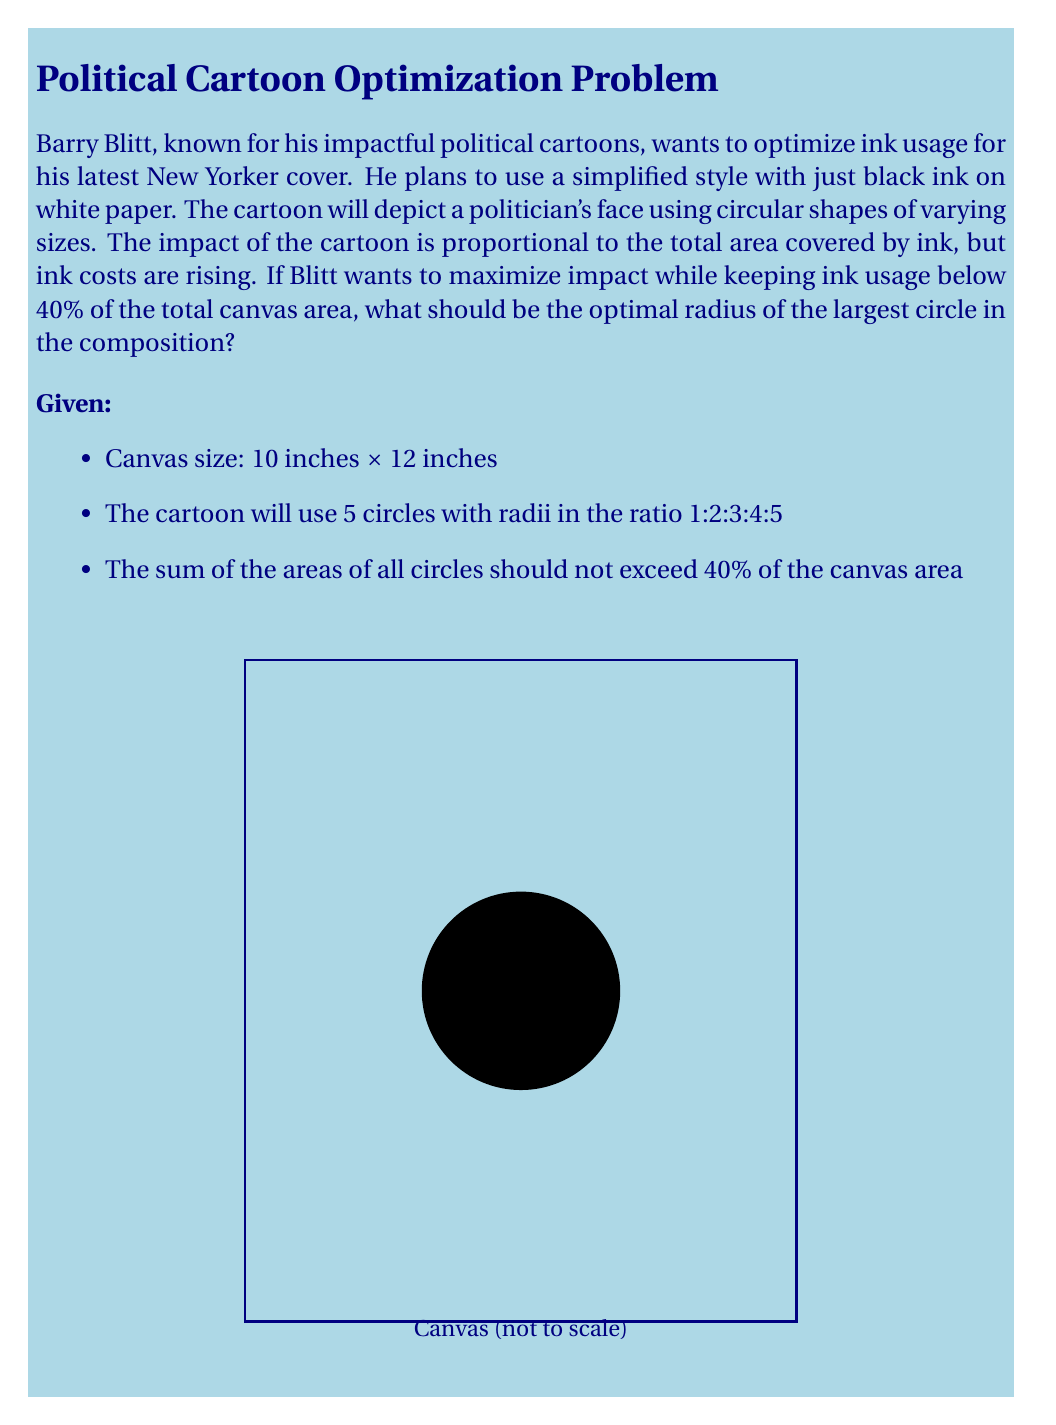Teach me how to tackle this problem. Let's approach this step-by-step:

1) First, calculate the total canvas area:
   $A_{canvas} = 10 \text{ in} \times 12 \text{ in} = 120 \text{ in}^2$

2) The maximum ink coverage should be 40% of this:
   $A_{max} = 0.4 \times 120 \text{ in}^2 = 48 \text{ in}^2$

3) Let $r$ be the radius of the largest circle. The radii of all circles will be:
   $\frac{r}{5}, \frac{2r}{5}, \frac{3r}{5}, \frac{4r}{5}, r$

4) The total area of all circles should be less than or equal to $A_{max}$:
   $$\pi(\frac{r^2}{25} + \frac{4r^2}{25} + \frac{9r^2}{25} + \frac{16r^2}{25} + r^2) \leq 48$$

5) Simplify the left side of the inequality:
   $$\pi r^2(\frac{1}{25} + \frac{4}{25} + \frac{9}{25} + \frac{16}{25} + 1) \leq 48$$
   $$\pi r^2(\frac{55}{25}) \leq 48$$

6) Solve for $r$:
   $$r^2 \leq \frac{48 \times 25}{\pi \times 55}$$
   $$r^2 \leq \frac{1200}{55\pi} \approx 6.93$$
   $$r \leq \sqrt{\frac{1200}{55\pi}} \approx 2.63$$

7) Therefore, the optimal radius of the largest circle should be approximately 2.63 inches to maximize impact while staying within the ink usage limit.
Answer: $r = \sqrt{\frac{1200}{55\pi}} \approx 2.63$ inches 